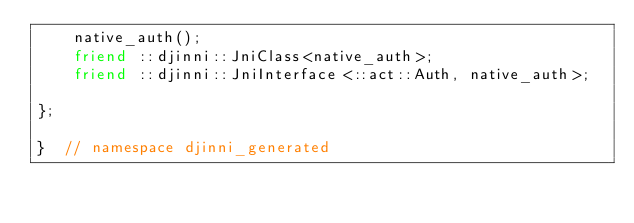<code> <loc_0><loc_0><loc_500><loc_500><_C++_>    native_auth();
    friend ::djinni::JniClass<native_auth>;
    friend ::djinni::JniInterface<::act::Auth, native_auth>;

};

}  // namespace djinni_generated
</code> 